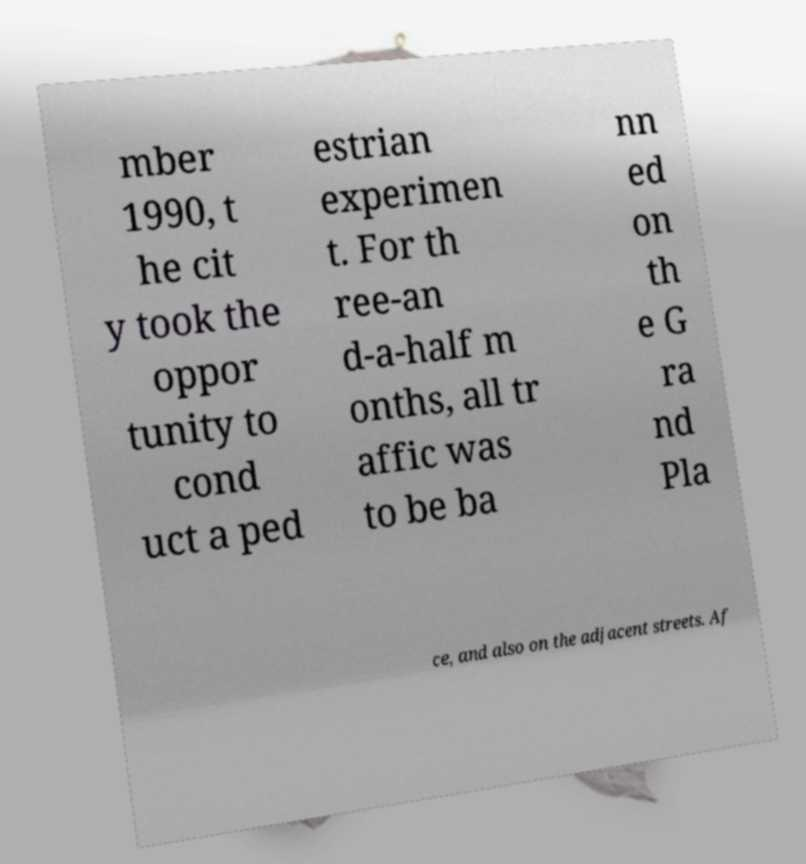I need the written content from this picture converted into text. Can you do that? mber 1990, t he cit y took the oppor tunity to cond uct a ped estrian experimen t. For th ree-an d-a-half m onths, all tr affic was to be ba nn ed on th e G ra nd Pla ce, and also on the adjacent streets. Af 